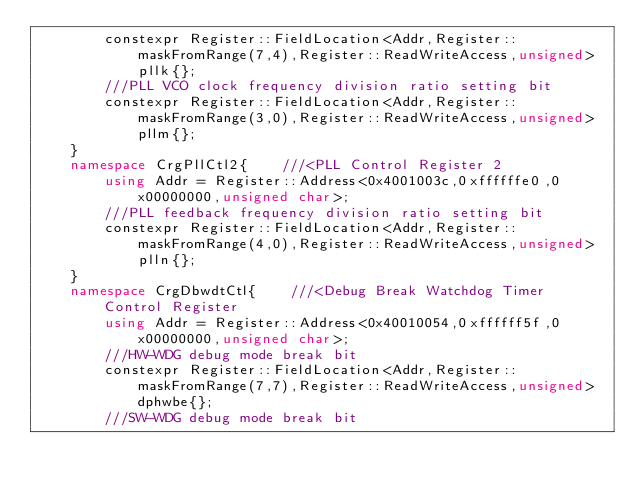<code> <loc_0><loc_0><loc_500><loc_500><_C++_>        constexpr Register::FieldLocation<Addr,Register::maskFromRange(7,4),Register::ReadWriteAccess,unsigned> pllk{}; 
        ///PLL VCO clock frequency division ratio setting bit 
        constexpr Register::FieldLocation<Addr,Register::maskFromRange(3,0),Register::ReadWriteAccess,unsigned> pllm{}; 
    }
    namespace CrgPllCtl2{    ///<PLL Control Register 2
        using Addr = Register::Address<0x4001003c,0xffffffe0,0x00000000,unsigned char>;
        ///PLL feedback frequency division ratio setting bit 
        constexpr Register::FieldLocation<Addr,Register::maskFromRange(4,0),Register::ReadWriteAccess,unsigned> plln{}; 
    }
    namespace CrgDbwdtCtl{    ///<Debug Break Watchdog Timer Control Register
        using Addr = Register::Address<0x40010054,0xffffff5f,0x00000000,unsigned char>;
        ///HW-WDG debug mode break bit 
        constexpr Register::FieldLocation<Addr,Register::maskFromRange(7,7),Register::ReadWriteAccess,unsigned> dphwbe{}; 
        ///SW-WDG debug mode break bit </code> 